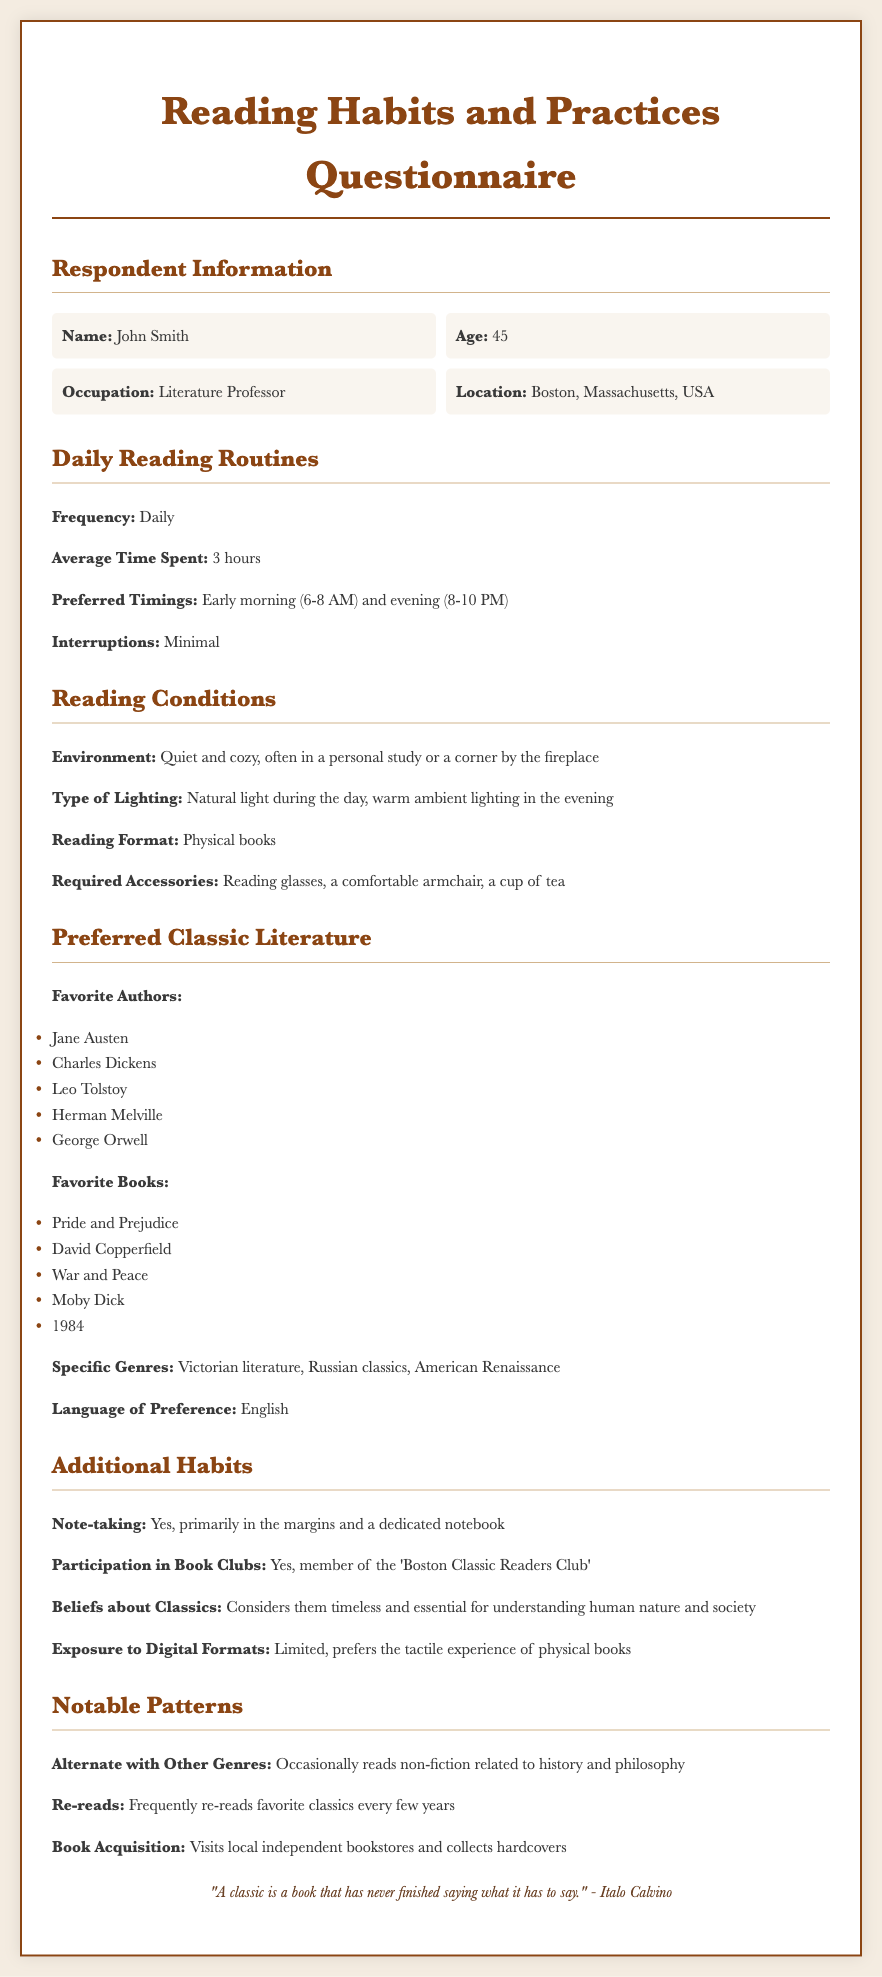What is the respondent's name? The name of the respondent is provided under Respondent Information.
Answer: John Smith What is the average time spent reading daily? The average time spent reading is mentioned in the Daily Reading Routines section.
Answer: 3 hours When does the respondent prefer to read? The preferred timings for reading are stated in the Daily Reading Routines.
Answer: Early morning (6-8 AM) and evening (8-10 PM) What is the reading format preference? The type of reading format is mentioned under Reading Conditions.
Answer: Physical books Which book is listed as a favorite? A favorite book is mentioned under Preferred Classic Literature.
Answer: Pride and Prejudice What is a specific genre the respondent enjoys? Specific genres are noted in the Preferred Classic Literature section.
Answer: Victorian literature How often does the respondent re-read classics? The frequency of re-reading is discussed in Notable Patterns.
Answer: Frequently What club is the respondent a member of? The name of the club is mentioned in Additional Habits.
Answer: Boston Classic Readers Club What is the respondent's belief about classics? The beliefs about classics are articulated in Additional Habits.
Answer: Timeless and essential for understanding human nature and society 